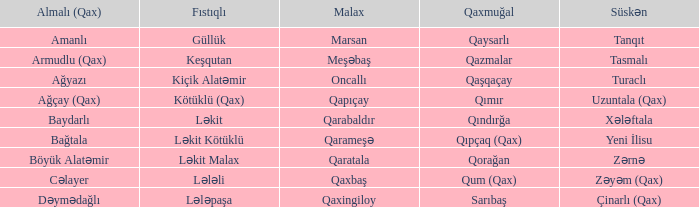What is the Qaxmuğal village with a Fistiqli village keşqutan? Qazmalar. 